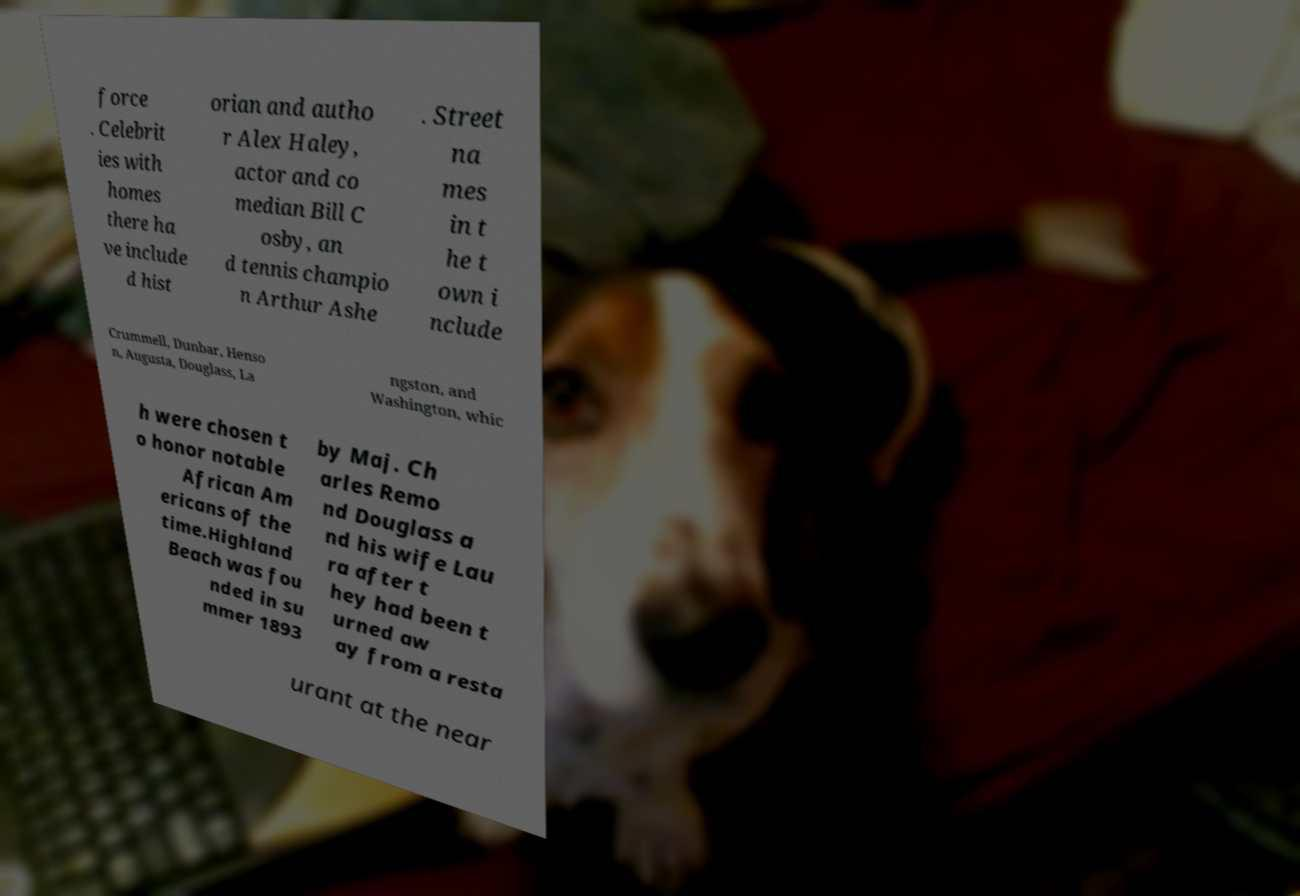I need the written content from this picture converted into text. Can you do that? force . Celebrit ies with homes there ha ve include d hist orian and autho r Alex Haley, actor and co median Bill C osby, an d tennis champio n Arthur Ashe . Street na mes in t he t own i nclude Crummell, Dunbar, Henso n, Augusta, Douglass, La ngston, and Washington, whic h were chosen t o honor notable African Am ericans of the time.Highland Beach was fou nded in su mmer 1893 by Maj. Ch arles Remo nd Douglass a nd his wife Lau ra after t hey had been t urned aw ay from a resta urant at the near 